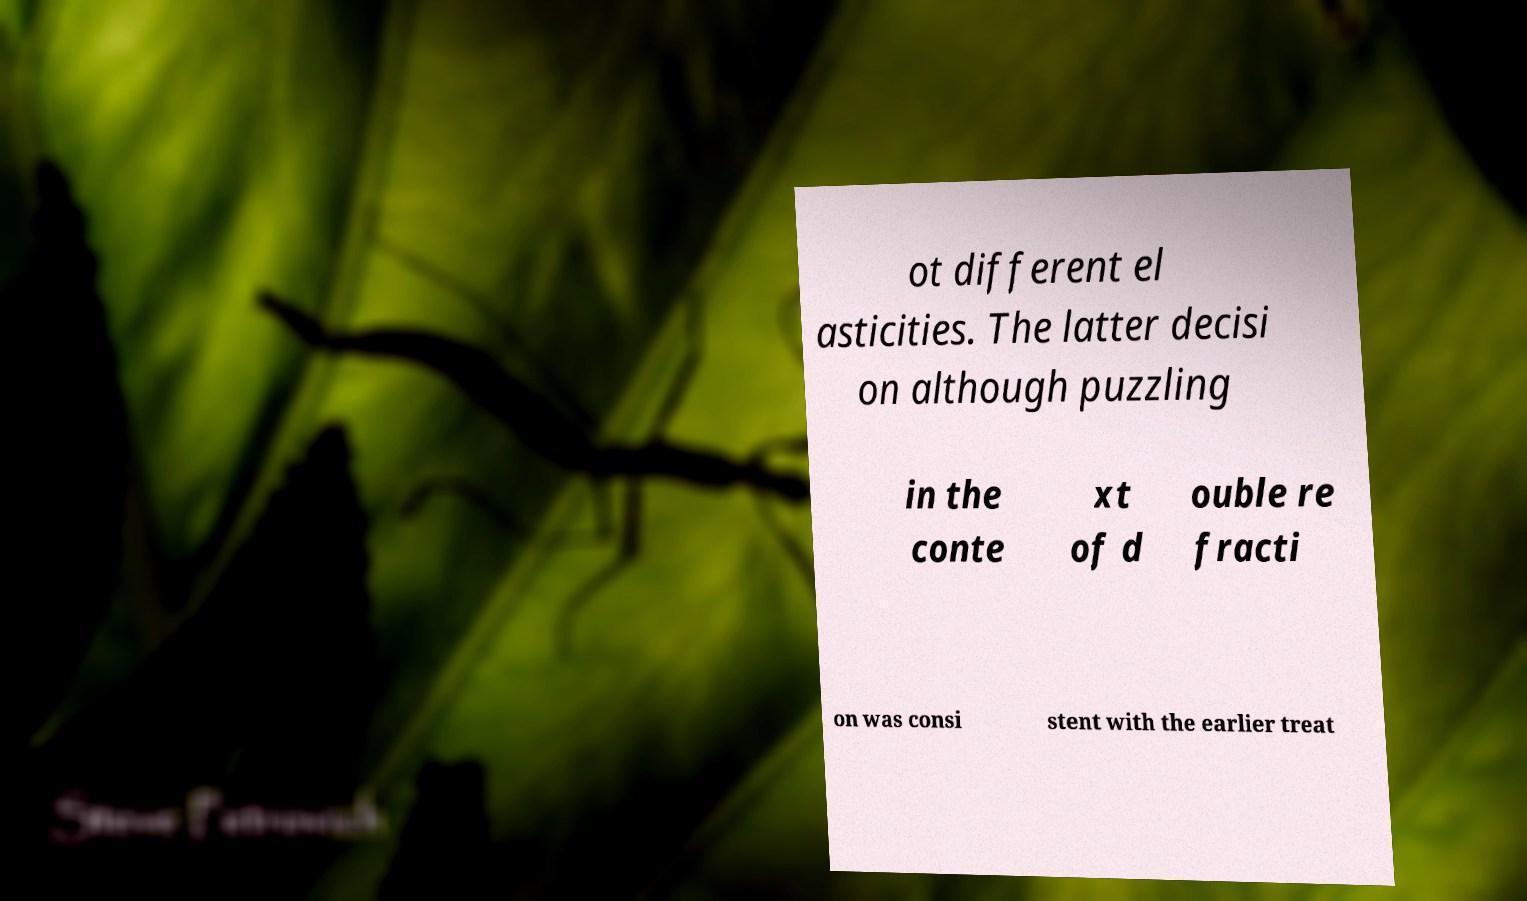Could you assist in decoding the text presented in this image and type it out clearly? ot different el asticities. The latter decisi on although puzzling in the conte xt of d ouble re fracti on was consi stent with the earlier treat 